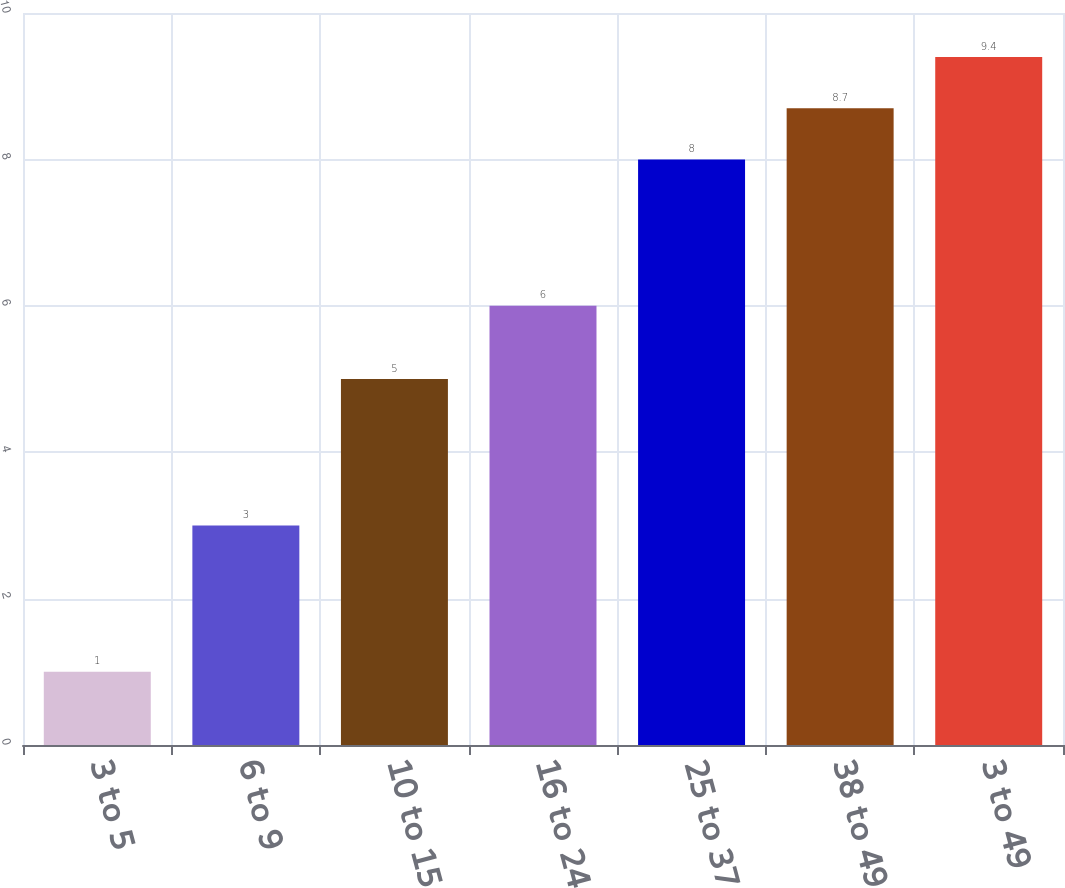Convert chart. <chart><loc_0><loc_0><loc_500><loc_500><bar_chart><fcel>3 to 5<fcel>6 to 9<fcel>10 to 15<fcel>16 to 24<fcel>25 to 37<fcel>38 to 49<fcel>3 to 49<nl><fcel>1<fcel>3<fcel>5<fcel>6<fcel>8<fcel>8.7<fcel>9.4<nl></chart> 